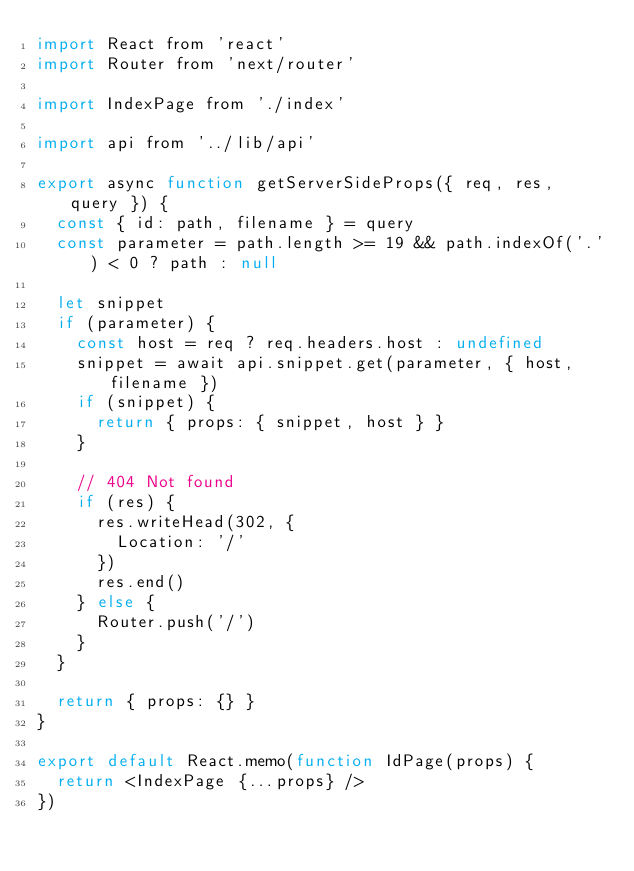Convert code to text. <code><loc_0><loc_0><loc_500><loc_500><_JavaScript_>import React from 'react'
import Router from 'next/router'

import IndexPage from './index'

import api from '../lib/api'

export async function getServerSideProps({ req, res, query }) {
  const { id: path, filename } = query
  const parameter = path.length >= 19 && path.indexOf('.') < 0 ? path : null

  let snippet
  if (parameter) {
    const host = req ? req.headers.host : undefined
    snippet = await api.snippet.get(parameter, { host, filename })
    if (snippet) {
      return { props: { snippet, host } }
    }

    // 404 Not found
    if (res) {
      res.writeHead(302, {
        Location: '/'
      })
      res.end()
    } else {
      Router.push('/')
    }
  }

  return { props: {} }
}

export default React.memo(function IdPage(props) {
  return <IndexPage {...props} />
})
</code> 